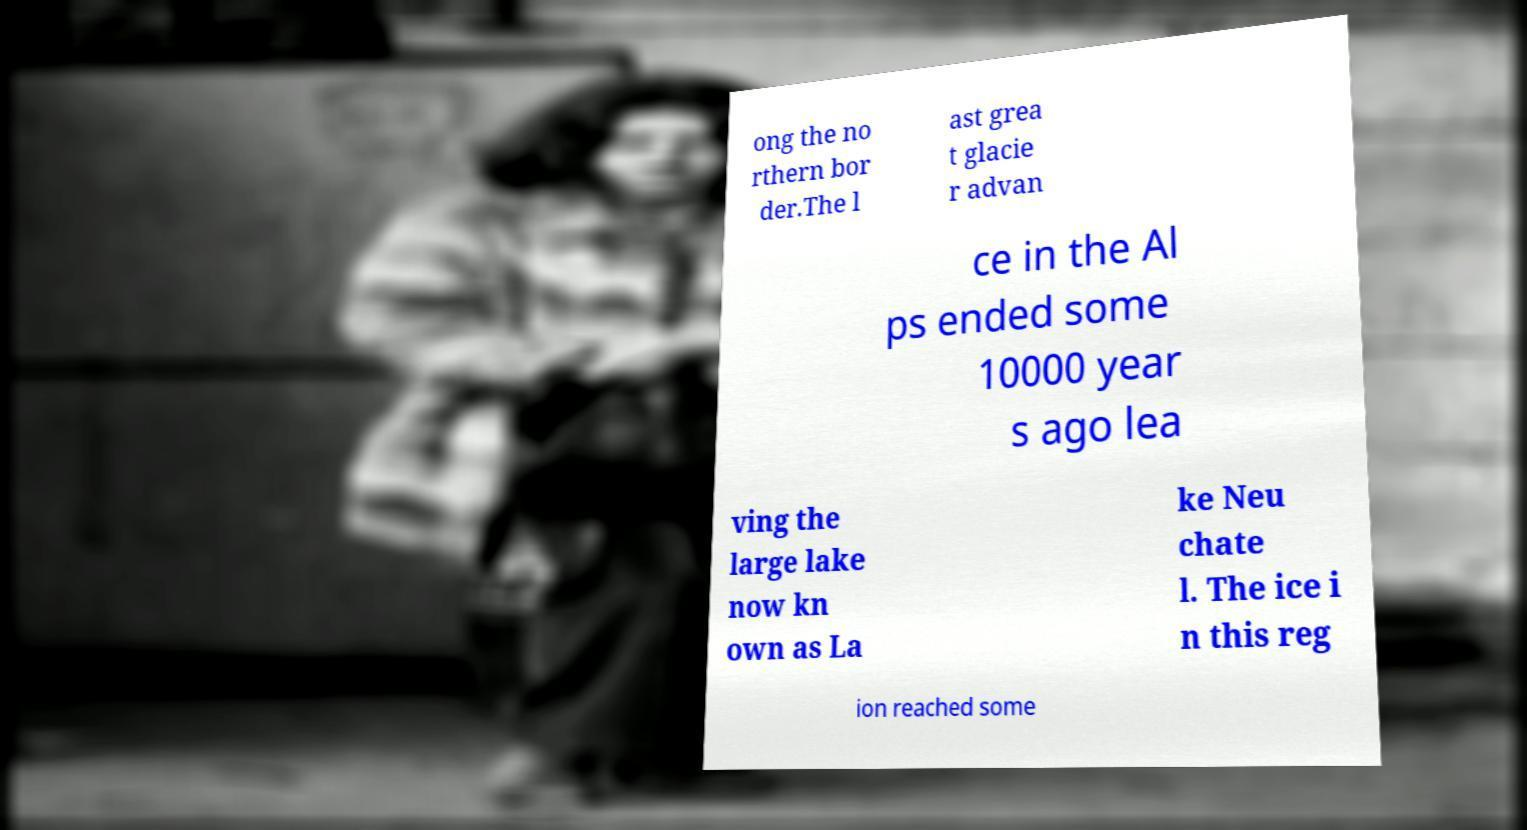Please read and relay the text visible in this image. What does it say? ong the no rthern bor der.The l ast grea t glacie r advan ce in the Al ps ended some 10000 year s ago lea ving the large lake now kn own as La ke Neu chate l. The ice i n this reg ion reached some 